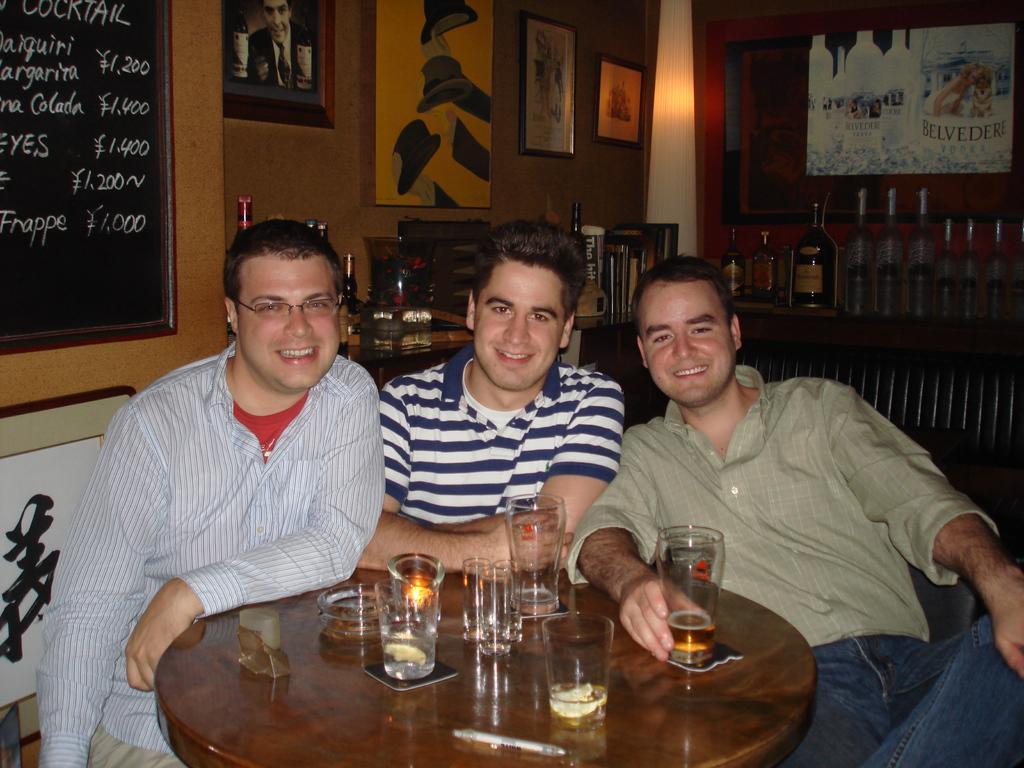Could you give a brief overview of what you see in this image? In this image three people are sitting and smiling. There are glasses on the table. At the left there is a blackboard. At the back there are photo frames on the wall. There are bottles and books on the table. 